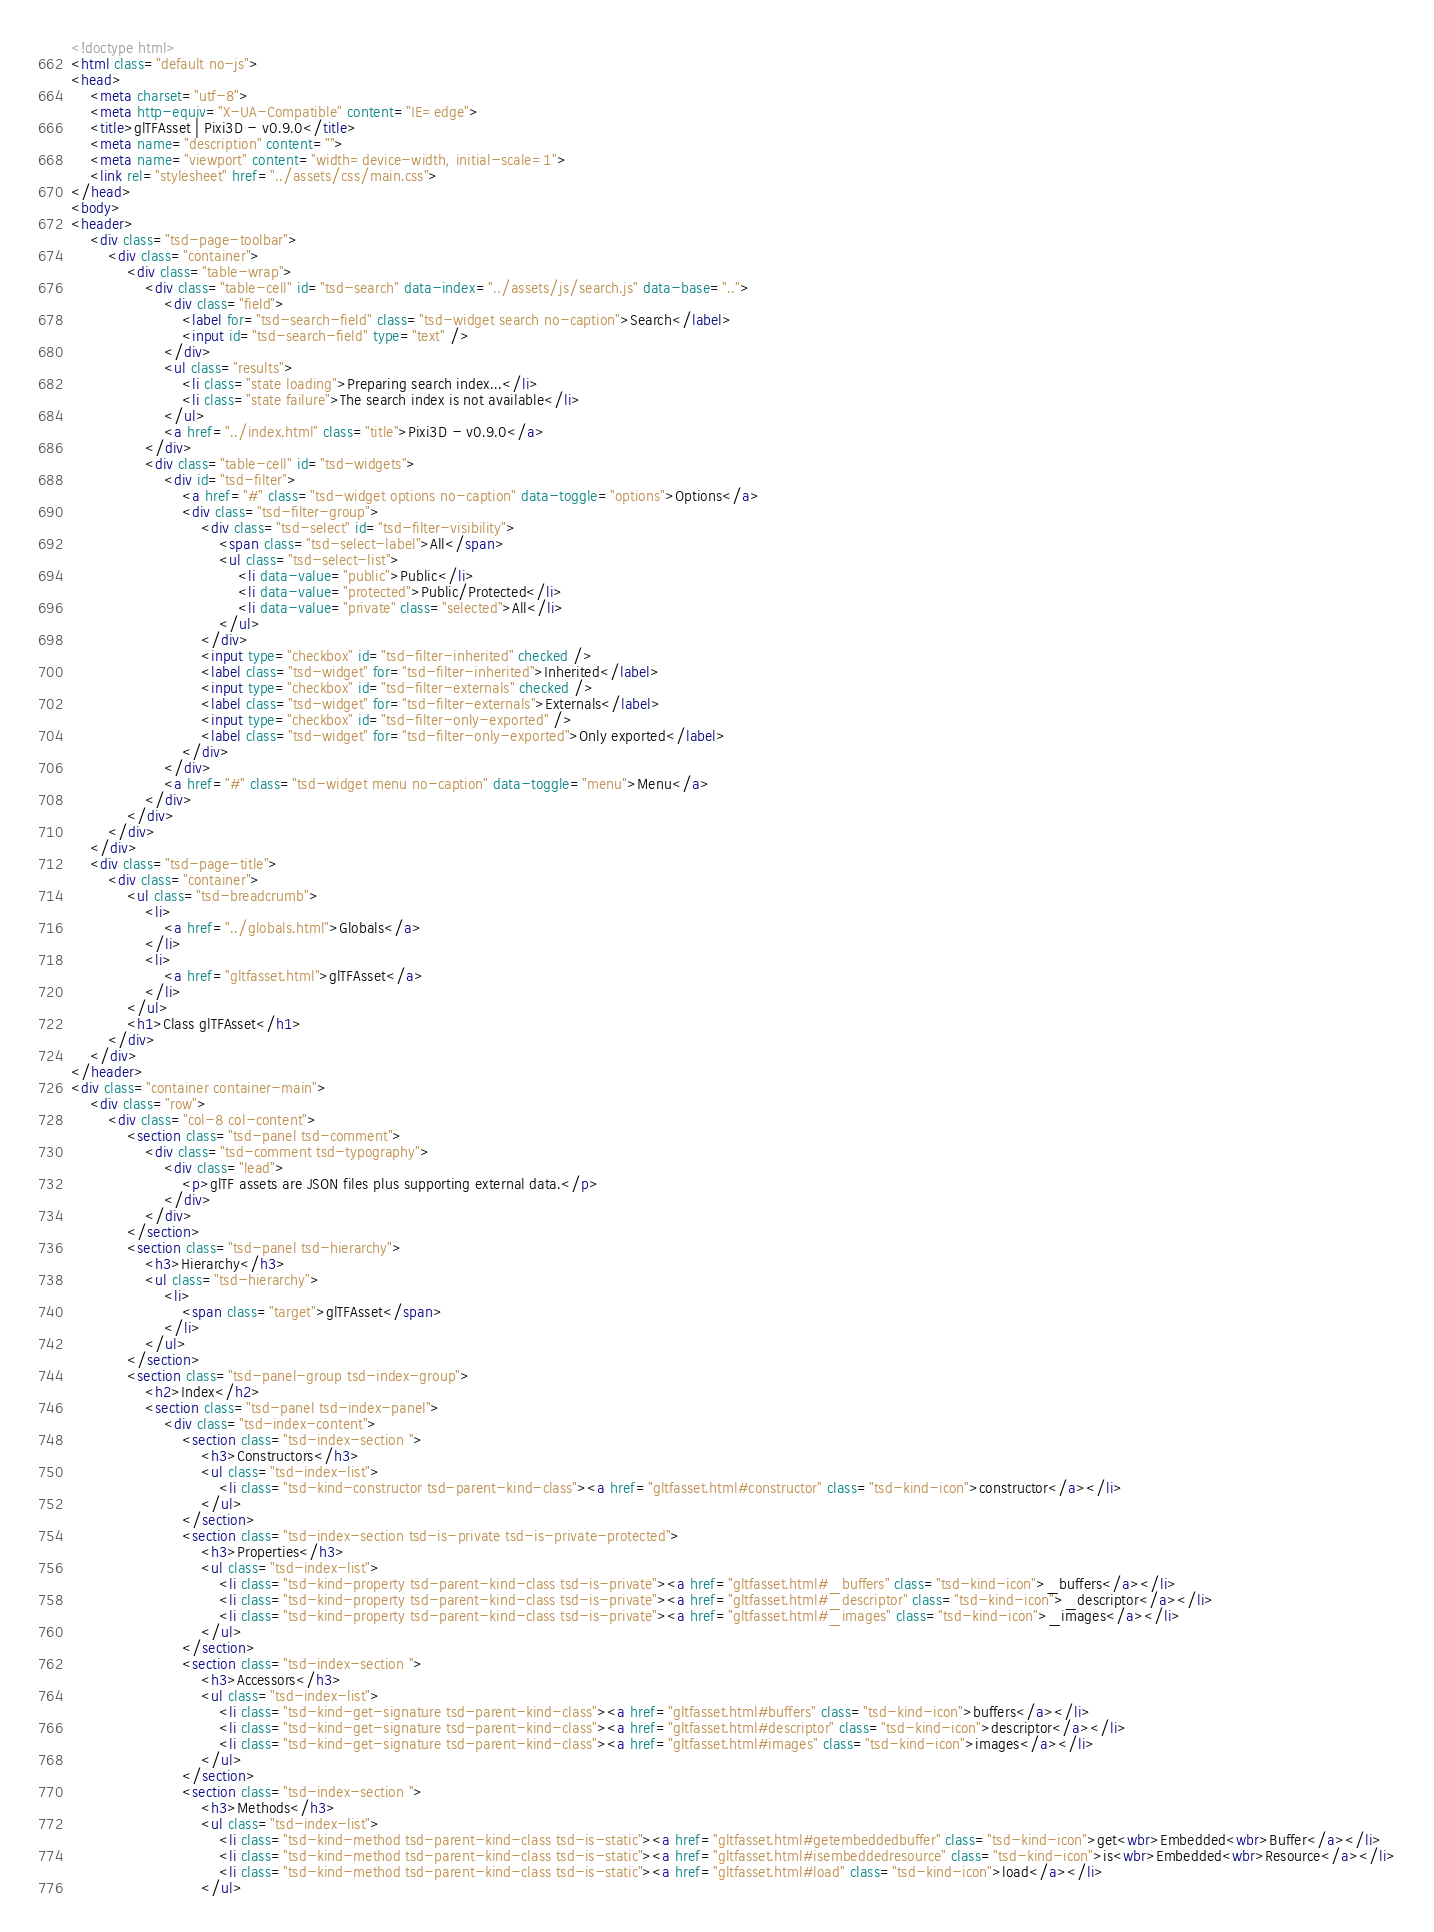Convert code to text. <code><loc_0><loc_0><loc_500><loc_500><_HTML_><!doctype html>
<html class="default no-js">
<head>
	<meta charset="utf-8">
	<meta http-equiv="X-UA-Compatible" content="IE=edge">
	<title>glTFAsset | Pixi3D - v0.9.0</title>
	<meta name="description" content="">
	<meta name="viewport" content="width=device-width, initial-scale=1">
	<link rel="stylesheet" href="../assets/css/main.css">
</head>
<body>
<header>
	<div class="tsd-page-toolbar">
		<div class="container">
			<div class="table-wrap">
				<div class="table-cell" id="tsd-search" data-index="../assets/js/search.js" data-base="..">
					<div class="field">
						<label for="tsd-search-field" class="tsd-widget search no-caption">Search</label>
						<input id="tsd-search-field" type="text" />
					</div>
					<ul class="results">
						<li class="state loading">Preparing search index...</li>
						<li class="state failure">The search index is not available</li>
					</ul>
					<a href="../index.html" class="title">Pixi3D - v0.9.0</a>
				</div>
				<div class="table-cell" id="tsd-widgets">
					<div id="tsd-filter">
						<a href="#" class="tsd-widget options no-caption" data-toggle="options">Options</a>
						<div class="tsd-filter-group">
							<div class="tsd-select" id="tsd-filter-visibility">
								<span class="tsd-select-label">All</span>
								<ul class="tsd-select-list">
									<li data-value="public">Public</li>
									<li data-value="protected">Public/Protected</li>
									<li data-value="private" class="selected">All</li>
								</ul>
							</div>
							<input type="checkbox" id="tsd-filter-inherited" checked />
							<label class="tsd-widget" for="tsd-filter-inherited">Inherited</label>
							<input type="checkbox" id="tsd-filter-externals" checked />
							<label class="tsd-widget" for="tsd-filter-externals">Externals</label>
							<input type="checkbox" id="tsd-filter-only-exported" />
							<label class="tsd-widget" for="tsd-filter-only-exported">Only exported</label>
						</div>
					</div>
					<a href="#" class="tsd-widget menu no-caption" data-toggle="menu">Menu</a>
				</div>
			</div>
		</div>
	</div>
	<div class="tsd-page-title">
		<div class="container">
			<ul class="tsd-breadcrumb">
				<li>
					<a href="../globals.html">Globals</a>
				</li>
				<li>
					<a href="gltfasset.html">glTFAsset</a>
				</li>
			</ul>
			<h1>Class glTFAsset</h1>
		</div>
	</div>
</header>
<div class="container container-main">
	<div class="row">
		<div class="col-8 col-content">
			<section class="tsd-panel tsd-comment">
				<div class="tsd-comment tsd-typography">
					<div class="lead">
						<p>glTF assets are JSON files plus supporting external data.</p>
					</div>
				</div>
			</section>
			<section class="tsd-panel tsd-hierarchy">
				<h3>Hierarchy</h3>
				<ul class="tsd-hierarchy">
					<li>
						<span class="target">glTFAsset</span>
					</li>
				</ul>
			</section>
			<section class="tsd-panel-group tsd-index-group">
				<h2>Index</h2>
				<section class="tsd-panel tsd-index-panel">
					<div class="tsd-index-content">
						<section class="tsd-index-section ">
							<h3>Constructors</h3>
							<ul class="tsd-index-list">
								<li class="tsd-kind-constructor tsd-parent-kind-class"><a href="gltfasset.html#constructor" class="tsd-kind-icon">constructor</a></li>
							</ul>
						</section>
						<section class="tsd-index-section tsd-is-private tsd-is-private-protected">
							<h3>Properties</h3>
							<ul class="tsd-index-list">
								<li class="tsd-kind-property tsd-parent-kind-class tsd-is-private"><a href="gltfasset.html#_buffers" class="tsd-kind-icon">_buffers</a></li>
								<li class="tsd-kind-property tsd-parent-kind-class tsd-is-private"><a href="gltfasset.html#_descriptor" class="tsd-kind-icon">_descriptor</a></li>
								<li class="tsd-kind-property tsd-parent-kind-class tsd-is-private"><a href="gltfasset.html#_images" class="tsd-kind-icon">_images</a></li>
							</ul>
						</section>
						<section class="tsd-index-section ">
							<h3>Accessors</h3>
							<ul class="tsd-index-list">
								<li class="tsd-kind-get-signature tsd-parent-kind-class"><a href="gltfasset.html#buffers" class="tsd-kind-icon">buffers</a></li>
								<li class="tsd-kind-get-signature tsd-parent-kind-class"><a href="gltfasset.html#descriptor" class="tsd-kind-icon">descriptor</a></li>
								<li class="tsd-kind-get-signature tsd-parent-kind-class"><a href="gltfasset.html#images" class="tsd-kind-icon">images</a></li>
							</ul>
						</section>
						<section class="tsd-index-section ">
							<h3>Methods</h3>
							<ul class="tsd-index-list">
								<li class="tsd-kind-method tsd-parent-kind-class tsd-is-static"><a href="gltfasset.html#getembeddedbuffer" class="tsd-kind-icon">get<wbr>Embedded<wbr>Buffer</a></li>
								<li class="tsd-kind-method tsd-parent-kind-class tsd-is-static"><a href="gltfasset.html#isembeddedresource" class="tsd-kind-icon">is<wbr>Embedded<wbr>Resource</a></li>
								<li class="tsd-kind-method tsd-parent-kind-class tsd-is-static"><a href="gltfasset.html#load" class="tsd-kind-icon">load</a></li>
							</ul></code> 